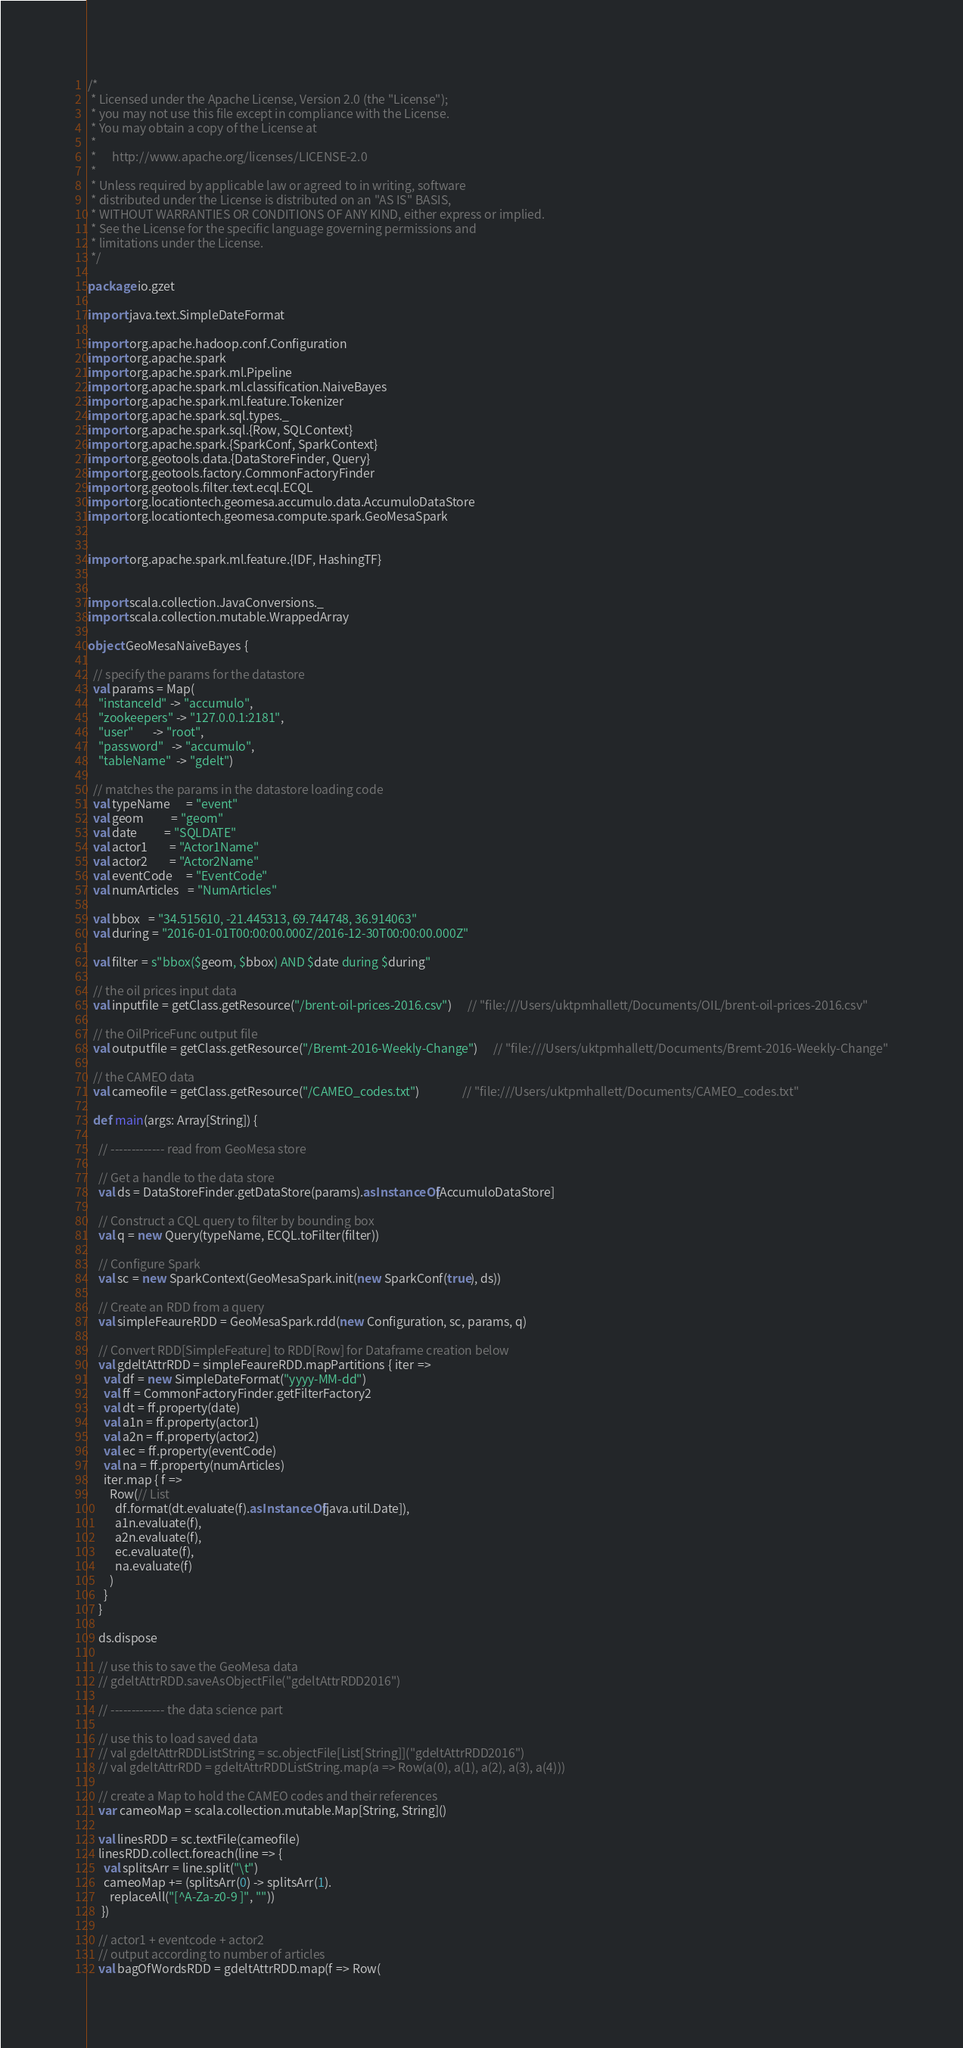<code> <loc_0><loc_0><loc_500><loc_500><_Scala_>/*
 * Licensed under the Apache License, Version 2.0 (the "License");
 * you may not use this file except in compliance with the License.
 * You may obtain a copy of the License at
 *
 *      http://www.apache.org/licenses/LICENSE-2.0
 *
 * Unless required by applicable law or agreed to in writing, software
 * distributed under the License is distributed on an "AS IS" BASIS,
 * WITHOUT WARRANTIES OR CONDITIONS OF ANY KIND, either express or implied.
 * See the License for the specific language governing permissions and
 * limitations under the License.
 */

package io.gzet

import java.text.SimpleDateFormat

import org.apache.hadoop.conf.Configuration
import org.apache.spark
import org.apache.spark.ml.Pipeline
import org.apache.spark.ml.classification.NaiveBayes
import org.apache.spark.ml.feature.Tokenizer
import org.apache.spark.sql.types._
import org.apache.spark.sql.{Row, SQLContext}
import org.apache.spark.{SparkConf, SparkContext}
import org.geotools.data.{DataStoreFinder, Query}
import org.geotools.factory.CommonFactoryFinder
import org.geotools.filter.text.ecql.ECQL
import org.locationtech.geomesa.accumulo.data.AccumuloDataStore
import org.locationtech.geomesa.compute.spark.GeoMesaSpark


import org.apache.spark.ml.feature.{IDF, HashingTF}


import scala.collection.JavaConversions._
import scala.collection.mutable.WrappedArray

object GeoMesaNaiveBayes {

  // specify the params for the datastore
  val params = Map(
    "instanceId" -> "accumulo",
    "zookeepers" -> "127.0.0.1:2181",
    "user"       -> "root",
    "password"   -> "accumulo",
    "tableName"  -> "gdelt")

  // matches the params in the datastore loading code
  val typeName      = "event"
  val geom          = "geom"
  val date          = "SQLDATE"
  val actor1        = "Actor1Name"
  val actor2        = "Actor2Name"
  val eventCode     = "EventCode"
  val numArticles   = "NumArticles"

  val bbox   = "34.515610, -21.445313, 69.744748, 36.914063"
  val during = "2016-01-01T00:00:00.000Z/2016-12-30T00:00:00.000Z"

  val filter = s"bbox($geom, $bbox) AND $date during $during"

  // the oil prices input data
  val inputfile = getClass.getResource("/brent-oil-prices-2016.csv")      // "file:///Users/uktpmhallett/Documents/OIL/brent-oil-prices-2016.csv"

  // the OilPriceFunc output file
  val outputfile = getClass.getResource("/Bremt-2016-Weekly-Change")      // "file:///Users/uktpmhallett/Documents/Bremt-2016-Weekly-Change"

  // the CAMEO data
  val cameofile = getClass.getResource("/CAMEO_codes.txt")                // "file:///Users/uktpmhallett/Documents/CAMEO_codes.txt"

  def main(args: Array[String]) {

    // ------------- read from GeoMesa store

    // Get a handle to the data store
    val ds = DataStoreFinder.getDataStore(params).asInstanceOf[AccumuloDataStore]

    // Construct a CQL query to filter by bounding box
    val q = new Query(typeName, ECQL.toFilter(filter))

    // Configure Spark
    val sc = new SparkContext(GeoMesaSpark.init(new SparkConf(true), ds))

    // Create an RDD from a query
    val simpleFeaureRDD = GeoMesaSpark.rdd(new Configuration, sc, params, q)

    // Convert RDD[SimpleFeature] to RDD[Row] for Dataframe creation below
    val gdeltAttrRDD = simpleFeaureRDD.mapPartitions { iter =>
      val df = new SimpleDateFormat("yyyy-MM-dd")
      val ff = CommonFactoryFinder.getFilterFactory2
      val dt = ff.property(date)
      val a1n = ff.property(actor1)
      val a2n = ff.property(actor2)
      val ec = ff.property(eventCode)
      val na = ff.property(numArticles)
      iter.map { f =>
        Row(// List
          df.format(dt.evaluate(f).asInstanceOf[java.util.Date]),
          a1n.evaluate(f),
          a2n.evaluate(f),
          ec.evaluate(f),
          na.evaluate(f)
        )
      }
    }

    ds.dispose

    // use this to save the GeoMesa data
    // gdeltAttrRDD.saveAsObjectFile("gdeltAttrRDD2016")

    // ------------- the data science part

    // use this to load saved data
    // val gdeltAttrRDDListString = sc.objectFile[List[String]]("gdeltAttrRDD2016")
    // val gdeltAttrRDD = gdeltAttrRDDListString.map(a => Row(a(0), a(1), a(2), a(3), a(4)))

    // create a Map to hold the CAMEO codes and their references
    var cameoMap = scala.collection.mutable.Map[String, String]()

    val linesRDD = sc.textFile(cameofile)
    linesRDD.collect.foreach(line => {
      val splitsArr = line.split("\t")
      cameoMap += (splitsArr(0) -> splitsArr(1).
        replaceAll("[^A-Za-z0-9 ]", ""))
     })

    // actor1 + eventcode + actor2
    // output according to number of articles
    val bagOfWordsRDD = gdeltAttrRDD.map(f => Row(</code> 